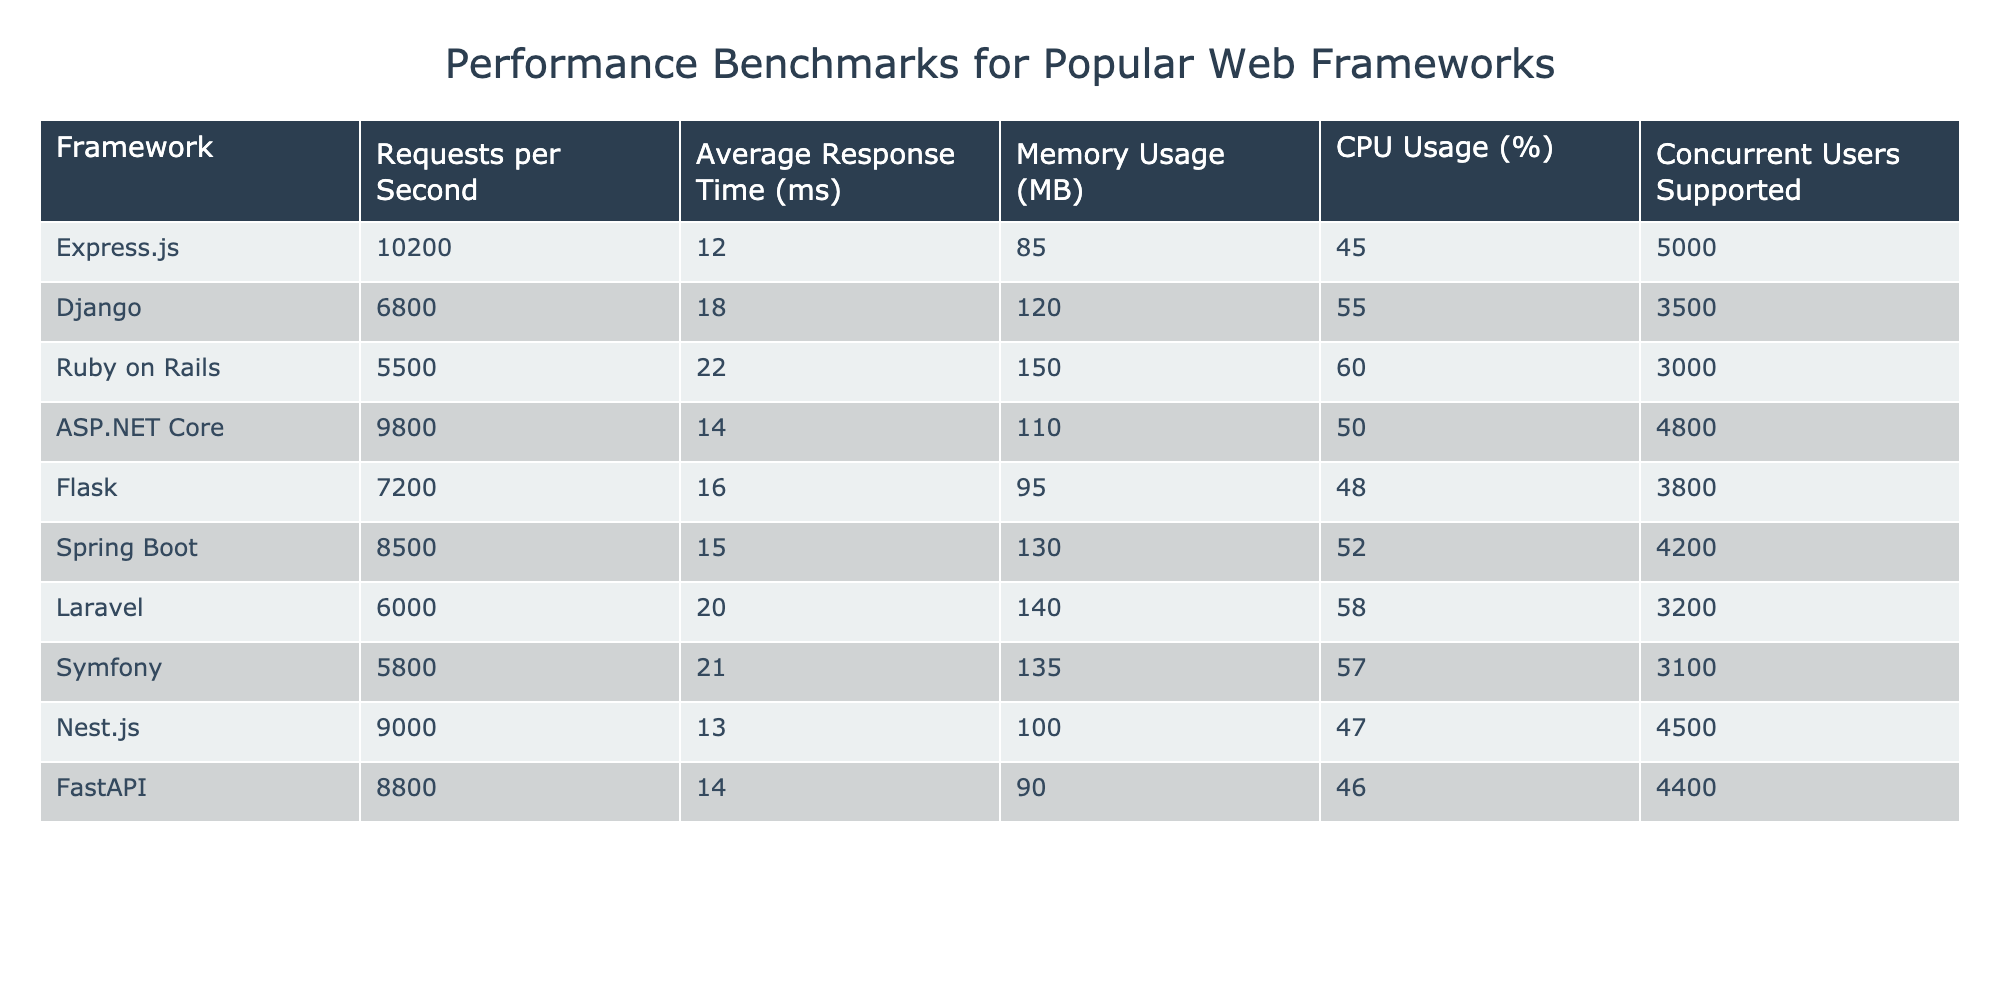What is the highest Requests per Second among the frameworks? By examining the "Requests per Second" column, I see that the maximum value is 10,200, associated with Express.js.
Answer: 10,200 Which web framework has the lowest Average Response Time? Looking at the "Average Response Time (ms)" column, the minimum value is 12 ms, which belongs to Express.js.
Answer: 12 ms How much Memory is used by Ruby on Rails? The "Memory Usage (MB)" column shows that Ruby on Rails uses 150 MB.
Answer: 150 MB What is the CPU Usage percentage of Flask? The "CPU Usage (%)" column indicates that Flask has a CPU Usage of 48%.
Answer: 48% If you combine the Requests per Second of ASP.NET Core and FastAPI, what would be the total? ASP.NET Core has 9,800 Requests per Second and FastAPI has 8,800. Adding them together gives 9,800 + 8,800 = 18,600.
Answer: 18,600 Which framework has better performance: Express.js or Django, based on Requests per Second? By comparing their Requests per Second values, Express.js has 10,200 and Django has 6,800. Since 10,200 is greater than 6,800, Express.js performs better.
Answer: Express.js Is it true that Laravel supports more concurrent users than Flask? In the "Concurrent Users Supported" column, Laravel supports 3,200 users while Flask supports 3,800 users, so it is not true.
Answer: No What is the difference in Memory Usage between Spring Boot and Ruby on Rails? Spring Boot uses 130 MB and Ruby on Rails uses 150 MB. The difference is 150 - 130 = 20 MB.
Answer: 20 MB Among the frameworks, which has the least Concurrent Users Supported? Looking at the "Concurrent Users Supported" column, Symfony has the least number of supported users with 3,100.
Answer: Symfony What average is calculated from the Requests per Second of Django, Ruby on Rails, and Laravel? The Requests per Second values for Django, Ruby on Rails, and Laravel are 6,800, 5,500, and 6,000, respectively. Summing them gives 6,800 + 5,500 + 6,000 = 18,300, and dividing by 3 results in an average of 18,300 / 3 = 6,100.
Answer: 6,100 Which framework has the highest CPU Usage, and what is that percentage? The "CPU Usage (%)" column shows that Ruby on Rails has the highest usage at 60%.
Answer: Ruby on Rails, 60% 